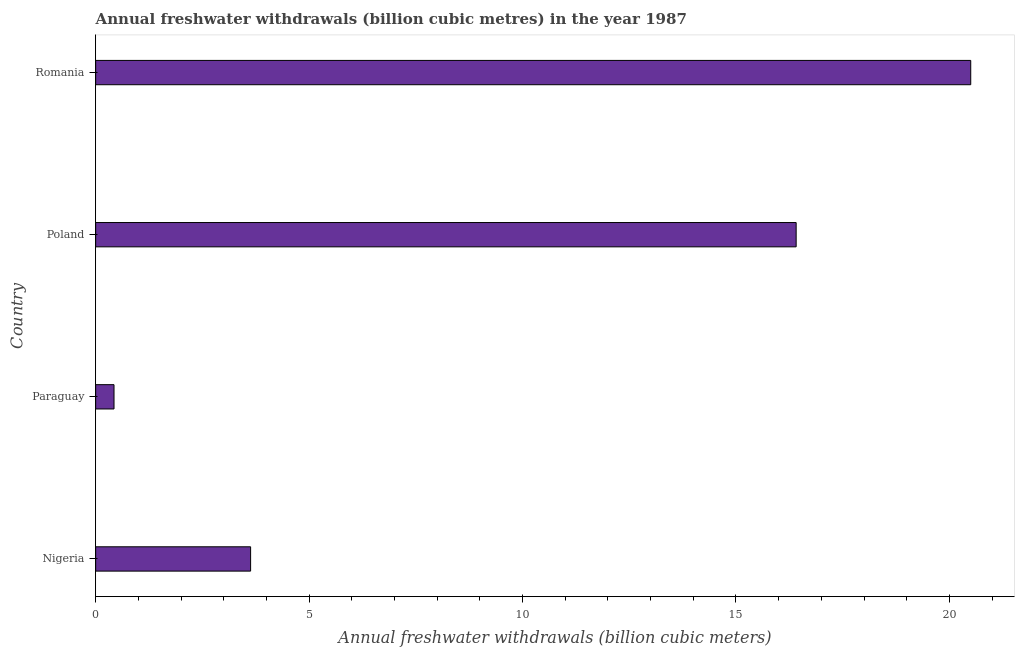Does the graph contain grids?
Provide a succinct answer. No. What is the title of the graph?
Your response must be concise. Annual freshwater withdrawals (billion cubic metres) in the year 1987. What is the label or title of the X-axis?
Your response must be concise. Annual freshwater withdrawals (billion cubic meters). What is the label or title of the Y-axis?
Offer a very short reply. Country. Across all countries, what is the minimum annual freshwater withdrawals?
Ensure brevity in your answer.  0.43. In which country was the annual freshwater withdrawals maximum?
Your answer should be compact. Romania. In which country was the annual freshwater withdrawals minimum?
Offer a terse response. Paraguay. What is the sum of the annual freshwater withdrawals?
Provide a short and direct response. 40.97. What is the difference between the annual freshwater withdrawals in Poland and Romania?
Your answer should be compact. -4.09. What is the average annual freshwater withdrawals per country?
Provide a succinct answer. 10.24. What is the median annual freshwater withdrawals?
Your answer should be very brief. 10.02. In how many countries, is the annual freshwater withdrawals greater than 18 billion cubic meters?
Your answer should be very brief. 1. What is the ratio of the annual freshwater withdrawals in Paraguay to that in Romania?
Your answer should be compact. 0.02. Is the annual freshwater withdrawals in Paraguay less than that in Poland?
Give a very brief answer. Yes. Is the difference between the annual freshwater withdrawals in Paraguay and Poland greater than the difference between any two countries?
Make the answer very short. No. What is the difference between the highest and the second highest annual freshwater withdrawals?
Give a very brief answer. 4.09. Is the sum of the annual freshwater withdrawals in Paraguay and Romania greater than the maximum annual freshwater withdrawals across all countries?
Your answer should be very brief. Yes. What is the difference between the highest and the lowest annual freshwater withdrawals?
Provide a short and direct response. 20.07. How many bars are there?
Make the answer very short. 4. Are all the bars in the graph horizontal?
Offer a very short reply. Yes. How many countries are there in the graph?
Make the answer very short. 4. What is the difference between two consecutive major ticks on the X-axis?
Your answer should be compact. 5. What is the Annual freshwater withdrawals (billion cubic meters) of Nigeria?
Make the answer very short. 3.63. What is the Annual freshwater withdrawals (billion cubic meters) of Paraguay?
Your answer should be very brief. 0.43. What is the Annual freshwater withdrawals (billion cubic meters) in Poland?
Your answer should be very brief. 16.41. What is the Annual freshwater withdrawals (billion cubic meters) in Romania?
Ensure brevity in your answer.  20.5. What is the difference between the Annual freshwater withdrawals (billion cubic meters) in Nigeria and Poland?
Provide a succinct answer. -12.78. What is the difference between the Annual freshwater withdrawals (billion cubic meters) in Nigeria and Romania?
Ensure brevity in your answer.  -16.87. What is the difference between the Annual freshwater withdrawals (billion cubic meters) in Paraguay and Poland?
Your answer should be very brief. -15.98. What is the difference between the Annual freshwater withdrawals (billion cubic meters) in Paraguay and Romania?
Keep it short and to the point. -20.07. What is the difference between the Annual freshwater withdrawals (billion cubic meters) in Poland and Romania?
Offer a very short reply. -4.09. What is the ratio of the Annual freshwater withdrawals (billion cubic meters) in Nigeria to that in Paraguay?
Provide a short and direct response. 8.44. What is the ratio of the Annual freshwater withdrawals (billion cubic meters) in Nigeria to that in Poland?
Your response must be concise. 0.22. What is the ratio of the Annual freshwater withdrawals (billion cubic meters) in Nigeria to that in Romania?
Offer a terse response. 0.18. What is the ratio of the Annual freshwater withdrawals (billion cubic meters) in Paraguay to that in Poland?
Your answer should be very brief. 0.03. What is the ratio of the Annual freshwater withdrawals (billion cubic meters) in Paraguay to that in Romania?
Your answer should be compact. 0.02. 